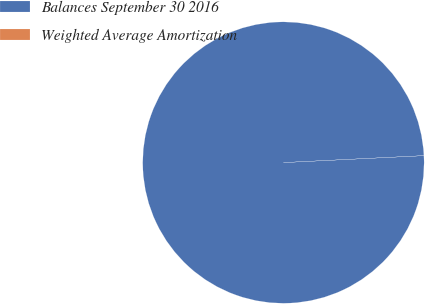Convert chart. <chart><loc_0><loc_0><loc_500><loc_500><pie_chart><fcel>Balances September 30 2016<fcel>Weighted Average Amortization<nl><fcel>100.0%<fcel>0.0%<nl></chart> 